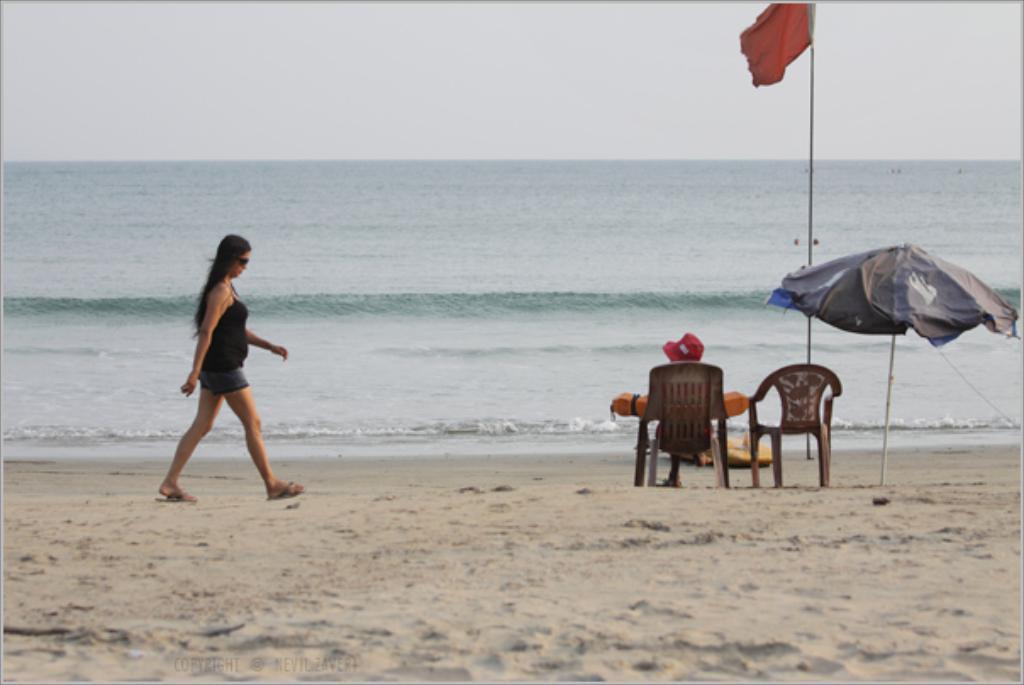Please provide a concise description of this image. A woman is walking in beach. A person is sitting in a chair and looking at sea. 